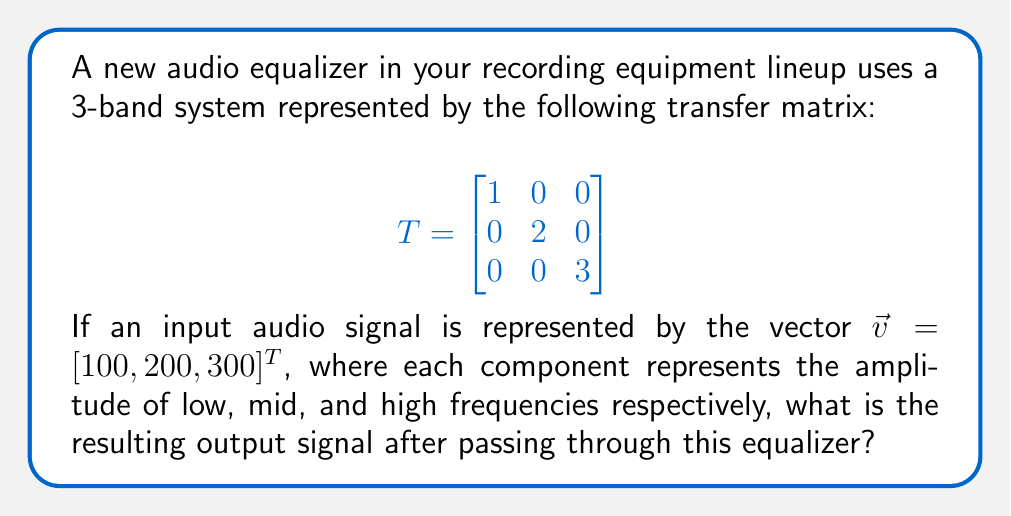Solve this math problem. To solve this problem, we need to apply the transfer matrix to the input signal vector. This is done through matrix multiplication.

Step 1: Set up the matrix multiplication
$$T\vec{v} = \begin{bmatrix}
1 & 0 & 0 \\
0 & 2 & 0 \\
0 & 0 & 3
\end{bmatrix} \begin{bmatrix}
100 \\
200 \\
300
\end{bmatrix}$$

Step 2: Perform the multiplication
$$\begin{bmatrix}
1(100) + 0(200) + 0(300) \\
0(100) + 2(200) + 0(300) \\
0(100) + 0(200) + 3(300)
\end{bmatrix}$$

Step 3: Simplify
$$\begin{bmatrix}
100 \\
400 \\
900
\end{bmatrix}$$

This resulting vector represents the output signal, where:
- The low frequency (100) remains unchanged
- The mid frequency (200) is doubled to 400
- The high frequency (300) is tripled to 900
Answer: $[100, 400, 900]^T$ 